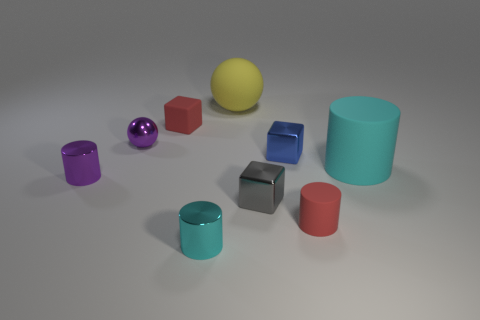Is there any other thing that has the same material as the tiny cyan thing?
Keep it short and to the point. Yes. The big cylinder is what color?
Offer a terse response. Cyan. Does the large matte cylinder have the same color as the small matte cylinder?
Keep it short and to the point. No. There is a tiny matte object that is right of the small rubber block; what number of tiny gray shiny blocks are on the left side of it?
Provide a short and direct response. 1. There is a metal thing that is behind the large matte cylinder and left of the yellow ball; what is its size?
Ensure brevity in your answer.  Small. What is the small red object that is to the right of the red matte cube made of?
Keep it short and to the point. Rubber. Is there a red rubber thing of the same shape as the cyan metallic object?
Provide a succinct answer. Yes. How many red matte objects are the same shape as the gray object?
Your response must be concise. 1. There is a metallic cylinder that is behind the gray shiny object; is it the same size as the cyan thing that is on the left side of the red cylinder?
Offer a very short reply. Yes. What is the shape of the tiny shiny thing that is in front of the red matte thing that is on the right side of the rubber sphere?
Your response must be concise. Cylinder. 